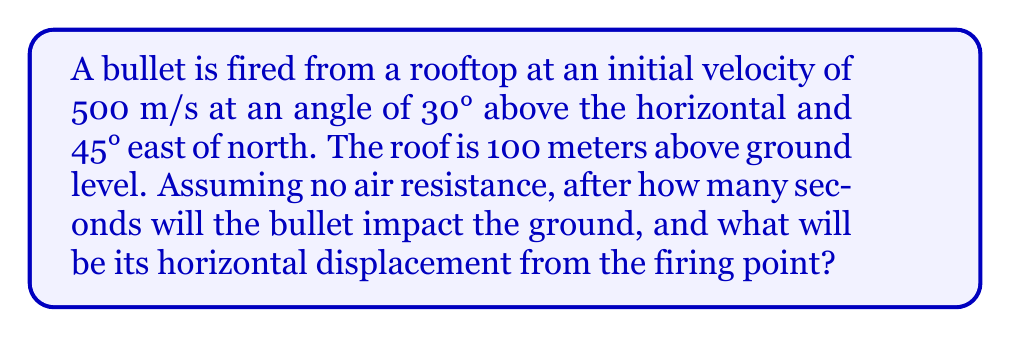Solve this math problem. Let's approach this step-by-step:

1) First, we need to break down the initial velocity into its components:

   $v_{x} = v \cos(30°) \cos(45°) = 500 \cdot \frac{\sqrt{3}}{2} \cdot \frac{\sqrt{2}}{2} = 306.19$ m/s
   $v_{y} = v \cos(30°) \sin(45°) = 500 \cdot \frac{\sqrt{3}}{2} \cdot \frac{\sqrt{2}}{2} = 306.19$ m/s
   $v_{z} = v \sin(30°) = 500 \cdot \frac{1}{2} = 250$ m/s

2) The time of flight can be calculated using the vertical motion equation:

   $z = z_0 + v_{z}t - \frac{1}{2}gt^2$

   Where $z_0 = 100$ m, $v_{z} = 250$ m/s, and $g = 9.8$ m/s²

3) At impact, $z = 0$:

   $0 = 100 + 250t - 4.9t^2$

4) Solving this quadratic equation:

   $4.9t^2 - 250t - 100 = 0$
   
   $t = \frac{250 \pm \sqrt{250^2 + 4(4.9)(100)}}{2(4.9)} = 51.53$ or $-0.51$ seconds

   We take the positive solution, so $t = 51.53$ seconds.

5) Now for the horizontal displacement, we use:

   $x = v_{x}t = 306.19 \cdot 51.53 = 15777.77$ m
   $y = v_{y}t = 306.19 \cdot 51.53 = 15777.77$ m

6) The total horizontal displacement is:

   $d = \sqrt{x^2 + y^2} = \sqrt{15777.77^2 + 15777.77^2} = 22312.59$ m
Answer: 51.53 seconds, 22312.59 meters 